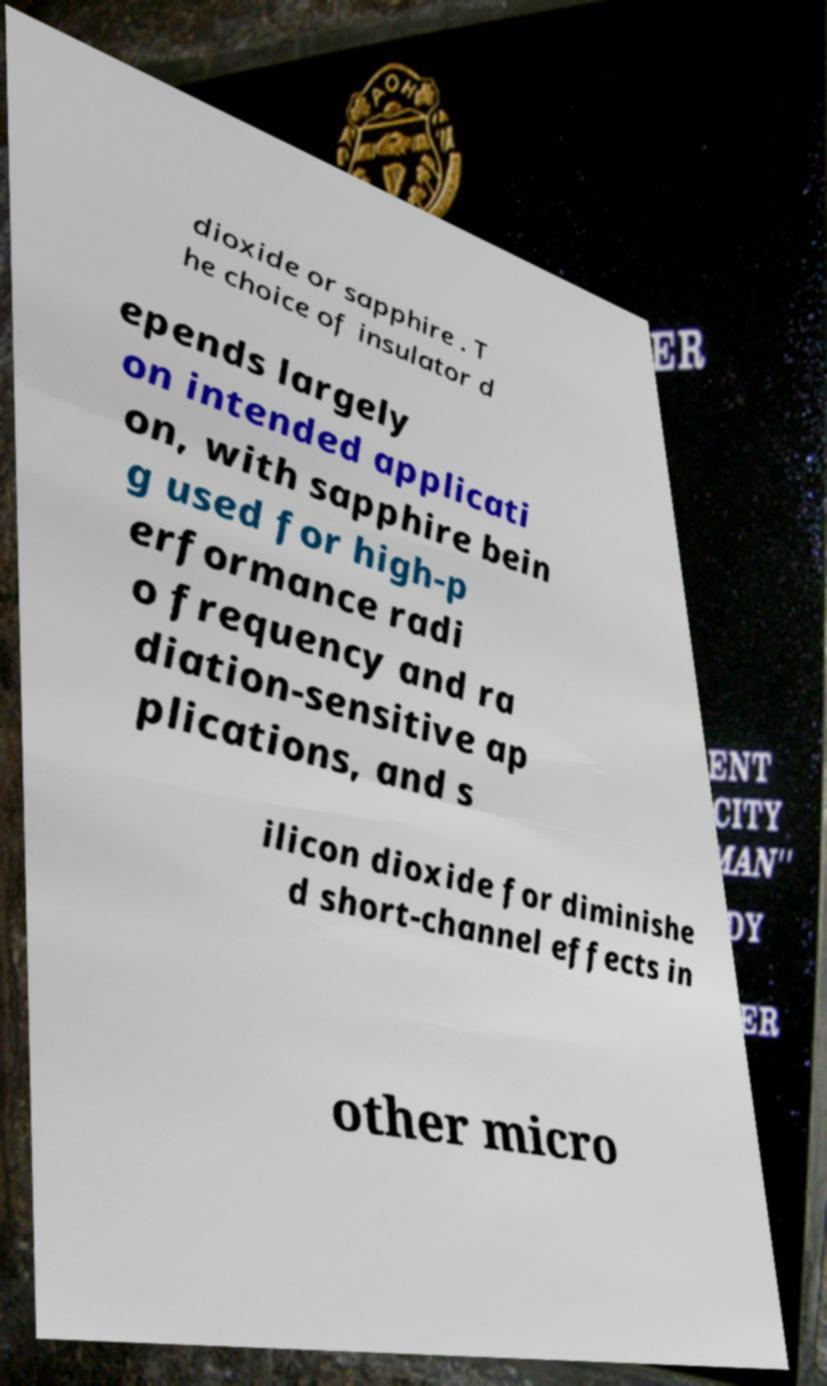I need the written content from this picture converted into text. Can you do that? dioxide or sapphire . T he choice of insulator d epends largely on intended applicati on, with sapphire bein g used for high-p erformance radi o frequency and ra diation-sensitive ap plications, and s ilicon dioxide for diminishe d short-channel effects in other micro 